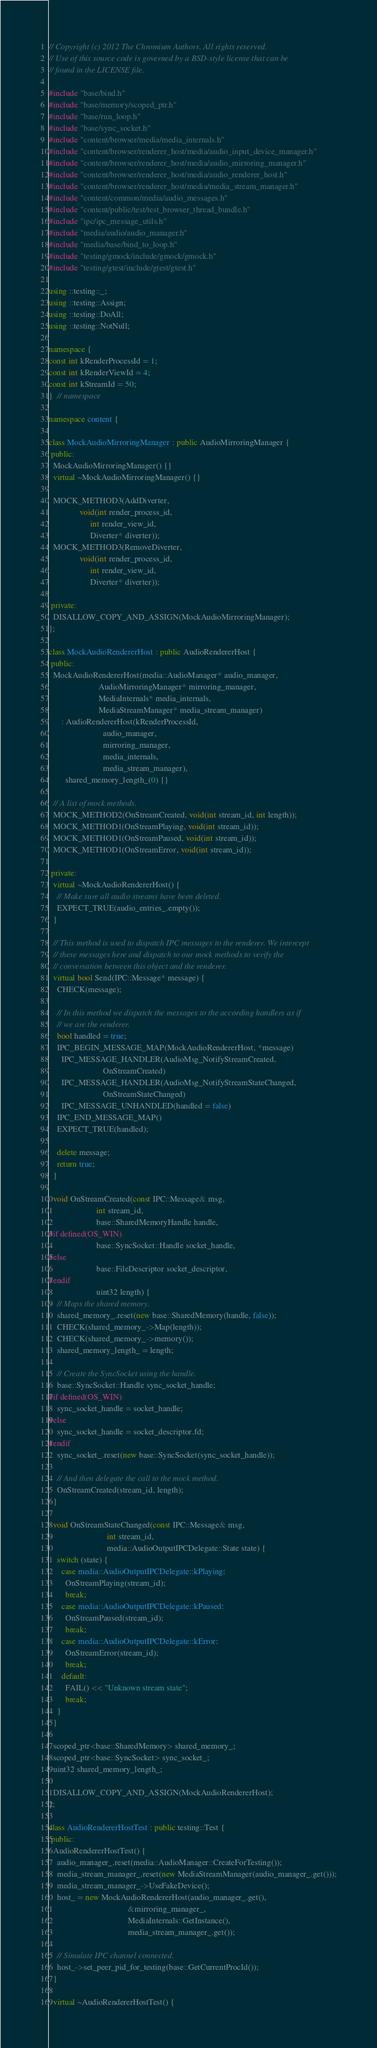<code> <loc_0><loc_0><loc_500><loc_500><_C++_>// Copyright (c) 2012 The Chromium Authors. All rights reserved.
// Use of this source code is governed by a BSD-style license that can be
// found in the LICENSE file.

#include "base/bind.h"
#include "base/memory/scoped_ptr.h"
#include "base/run_loop.h"
#include "base/sync_socket.h"
#include "content/browser/media/media_internals.h"
#include "content/browser/renderer_host/media/audio_input_device_manager.h"
#include "content/browser/renderer_host/media/audio_mirroring_manager.h"
#include "content/browser/renderer_host/media/audio_renderer_host.h"
#include "content/browser/renderer_host/media/media_stream_manager.h"
#include "content/common/media/audio_messages.h"
#include "content/public/test/test_browser_thread_bundle.h"
#include "ipc/ipc_message_utils.h"
#include "media/audio/audio_manager.h"
#include "media/base/bind_to_loop.h"
#include "testing/gmock/include/gmock/gmock.h"
#include "testing/gtest/include/gtest/gtest.h"

using ::testing::_;
using ::testing::Assign;
using ::testing::DoAll;
using ::testing::NotNull;

namespace {
const int kRenderProcessId = 1;
const int kRenderViewId = 4;
const int kStreamId = 50;
}  // namespace

namespace content {

class MockAudioMirroringManager : public AudioMirroringManager {
 public:
  MockAudioMirroringManager() {}
  virtual ~MockAudioMirroringManager() {}

  MOCK_METHOD3(AddDiverter,
               void(int render_process_id,
                    int render_view_id,
                    Diverter* diverter));
  MOCK_METHOD3(RemoveDiverter,
               void(int render_process_id,
                    int render_view_id,
                    Diverter* diverter));

 private:
  DISALLOW_COPY_AND_ASSIGN(MockAudioMirroringManager);
};

class MockAudioRendererHost : public AudioRendererHost {
 public:
  MockAudioRendererHost(media::AudioManager* audio_manager,
                        AudioMirroringManager* mirroring_manager,
                        MediaInternals* media_internals,
                        MediaStreamManager* media_stream_manager)
      : AudioRendererHost(kRenderProcessId,
                          audio_manager,
                          mirroring_manager,
                          media_internals,
                          media_stream_manager),
        shared_memory_length_(0) {}

  // A list of mock methods.
  MOCK_METHOD2(OnStreamCreated, void(int stream_id, int length));
  MOCK_METHOD1(OnStreamPlaying, void(int stream_id));
  MOCK_METHOD1(OnStreamPaused, void(int stream_id));
  MOCK_METHOD1(OnStreamError, void(int stream_id));

 private:
  virtual ~MockAudioRendererHost() {
    // Make sure all audio streams have been deleted.
    EXPECT_TRUE(audio_entries_.empty());
  }

  // This method is used to dispatch IPC messages to the renderer. We intercept
  // these messages here and dispatch to our mock methods to verify the
  // conversation between this object and the renderer.
  virtual bool Send(IPC::Message* message) {
    CHECK(message);

    // In this method we dispatch the messages to the according handlers as if
    // we are the renderer.
    bool handled = true;
    IPC_BEGIN_MESSAGE_MAP(MockAudioRendererHost, *message)
      IPC_MESSAGE_HANDLER(AudioMsg_NotifyStreamCreated,
                          OnStreamCreated)
      IPC_MESSAGE_HANDLER(AudioMsg_NotifyStreamStateChanged,
                          OnStreamStateChanged)
      IPC_MESSAGE_UNHANDLED(handled = false)
    IPC_END_MESSAGE_MAP()
    EXPECT_TRUE(handled);

    delete message;
    return true;
  }

  void OnStreamCreated(const IPC::Message& msg,
                       int stream_id,
                       base::SharedMemoryHandle handle,
#if defined(OS_WIN)
                       base::SyncSocket::Handle socket_handle,
#else
                       base::FileDescriptor socket_descriptor,
#endif
                       uint32 length) {
    // Maps the shared memory.
    shared_memory_.reset(new base::SharedMemory(handle, false));
    CHECK(shared_memory_->Map(length));
    CHECK(shared_memory_->memory());
    shared_memory_length_ = length;

    // Create the SyncSocket using the handle.
    base::SyncSocket::Handle sync_socket_handle;
#if defined(OS_WIN)
    sync_socket_handle = socket_handle;
#else
    sync_socket_handle = socket_descriptor.fd;
#endif
    sync_socket_.reset(new base::SyncSocket(sync_socket_handle));

    // And then delegate the call to the mock method.
    OnStreamCreated(stream_id, length);
  }

  void OnStreamStateChanged(const IPC::Message& msg,
                            int stream_id,
                            media::AudioOutputIPCDelegate::State state) {
    switch (state) {
      case media::AudioOutputIPCDelegate::kPlaying:
        OnStreamPlaying(stream_id);
        break;
      case media::AudioOutputIPCDelegate::kPaused:
        OnStreamPaused(stream_id);
        break;
      case media::AudioOutputIPCDelegate::kError:
        OnStreamError(stream_id);
        break;
      default:
        FAIL() << "Unknown stream state";
        break;
    }
  }

  scoped_ptr<base::SharedMemory> shared_memory_;
  scoped_ptr<base::SyncSocket> sync_socket_;
  uint32 shared_memory_length_;

  DISALLOW_COPY_AND_ASSIGN(MockAudioRendererHost);
};

class AudioRendererHostTest : public testing::Test {
 public:
  AudioRendererHostTest() {
    audio_manager_.reset(media::AudioManager::CreateForTesting());
    media_stream_manager_.reset(new MediaStreamManager(audio_manager_.get()));
    media_stream_manager_->UseFakeDevice();
    host_ = new MockAudioRendererHost(audio_manager_.get(),
                                      &mirroring_manager_,
                                      MediaInternals::GetInstance(),
                                      media_stream_manager_.get());

    // Simulate IPC channel connected.
    host_->set_peer_pid_for_testing(base::GetCurrentProcId());
  }

  virtual ~AudioRendererHostTest() {</code> 